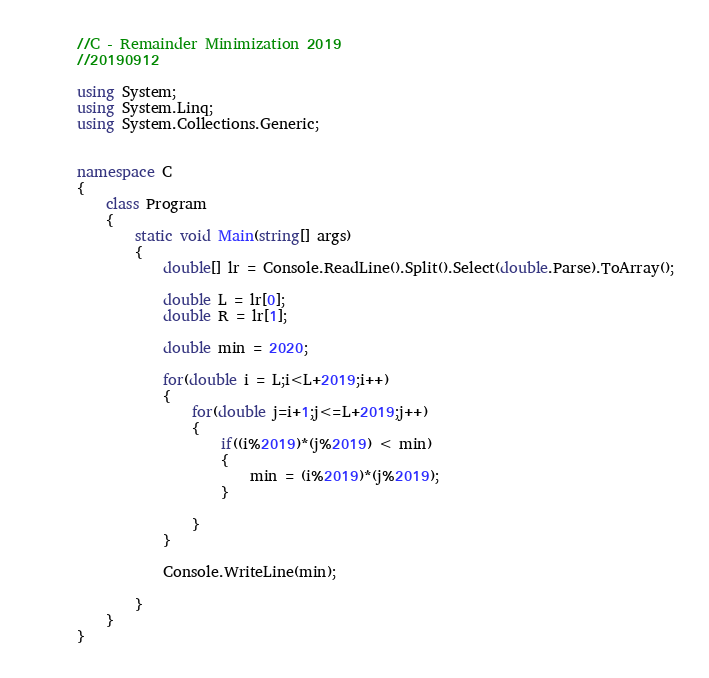<code> <loc_0><loc_0><loc_500><loc_500><_C#_>//C - Remainder Minimization 2019
//20190912

using System;
using System.Linq;
using System.Collections.Generic;


namespace C
{
    class Program
    {
        static void Main(string[] args)
        {
            double[] lr = Console.ReadLine().Split().Select(double.Parse).ToArray();

            double L = lr[0];
            double R = lr[1];
            
            double min = 2020;

            for(double i = L;i<L+2019;i++)
            {
                for(double j=i+1;j<=L+2019;j++)
                {
                    if((i%2019)*(j%2019) < min)
                    {
                        min = (i%2019)*(j%2019);
                    }

                }
            }

            Console.WriteLine(min);

        }
    }
}
</code> 